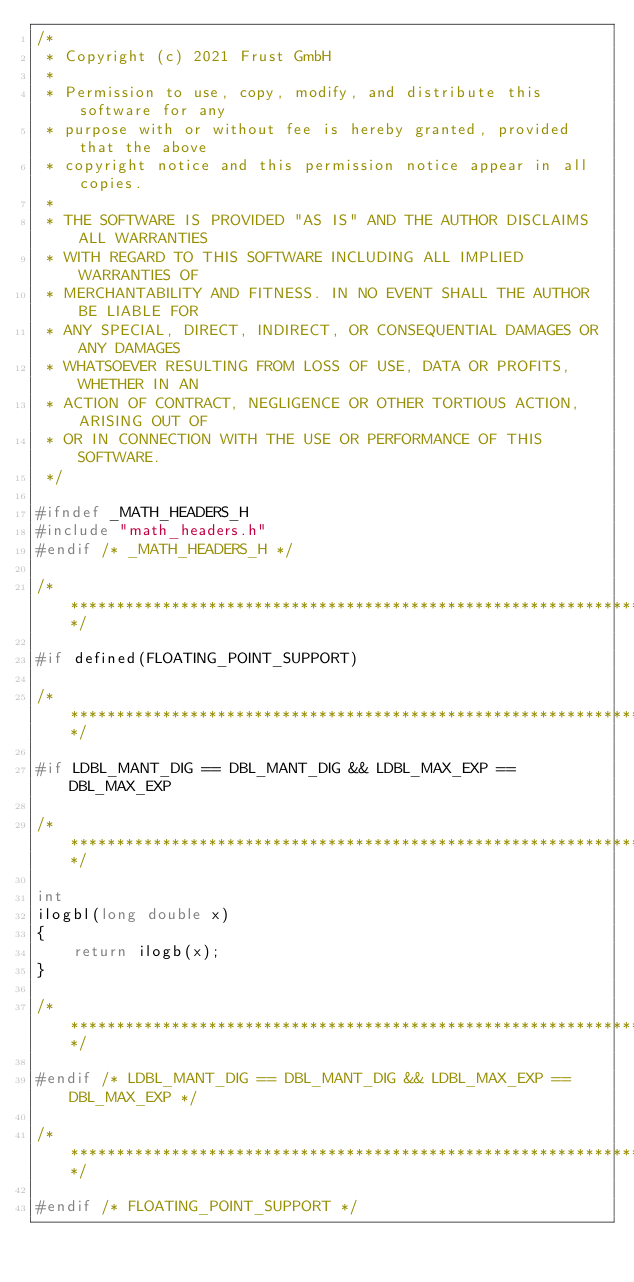<code> <loc_0><loc_0><loc_500><loc_500><_C_>/*
 * Copyright (c) 2021 Frust GmbH
 *
 * Permission to use, copy, modify, and distribute this software for any
 * purpose with or without fee is hereby granted, provided that the above
 * copyright notice and this permission notice appear in all copies.
 *
 * THE SOFTWARE IS PROVIDED "AS IS" AND THE AUTHOR DISCLAIMS ALL WARRANTIES
 * WITH REGARD TO THIS SOFTWARE INCLUDING ALL IMPLIED WARRANTIES OF
 * MERCHANTABILITY AND FITNESS. IN NO EVENT SHALL THE AUTHOR BE LIABLE FOR
 * ANY SPECIAL, DIRECT, INDIRECT, OR CONSEQUENTIAL DAMAGES OR ANY DAMAGES
 * WHATSOEVER RESULTING FROM LOSS OF USE, DATA OR PROFITS, WHETHER IN AN
 * ACTION OF CONTRACT, NEGLIGENCE OR OTHER TORTIOUS ACTION, ARISING OUT OF
 * OR IN CONNECTION WITH THE USE OR PERFORMANCE OF THIS SOFTWARE.
 */

#ifndef _MATH_HEADERS_H
#include "math_headers.h"
#endif /* _MATH_HEADERS_H */

/****************************************************************************/

#if defined(FLOATING_POINT_SUPPORT)

/****************************************************************************/

#if LDBL_MANT_DIG == DBL_MANT_DIG && LDBL_MAX_EXP == DBL_MAX_EXP

/****************************************************************************/

int
ilogbl(long double x)
{
	return ilogb(x);
}

/****************************************************************************/

#endif /* LDBL_MANT_DIG == DBL_MANT_DIG && LDBL_MAX_EXP == DBL_MAX_EXP */

/****************************************************************************/

#endif /* FLOATING_POINT_SUPPORT */
</code> 